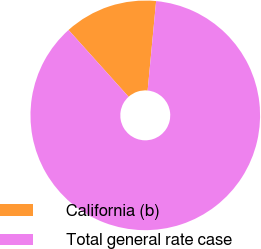<chart> <loc_0><loc_0><loc_500><loc_500><pie_chart><fcel>California (b)<fcel>Total general rate case<nl><fcel>13.16%<fcel>86.84%<nl></chart> 